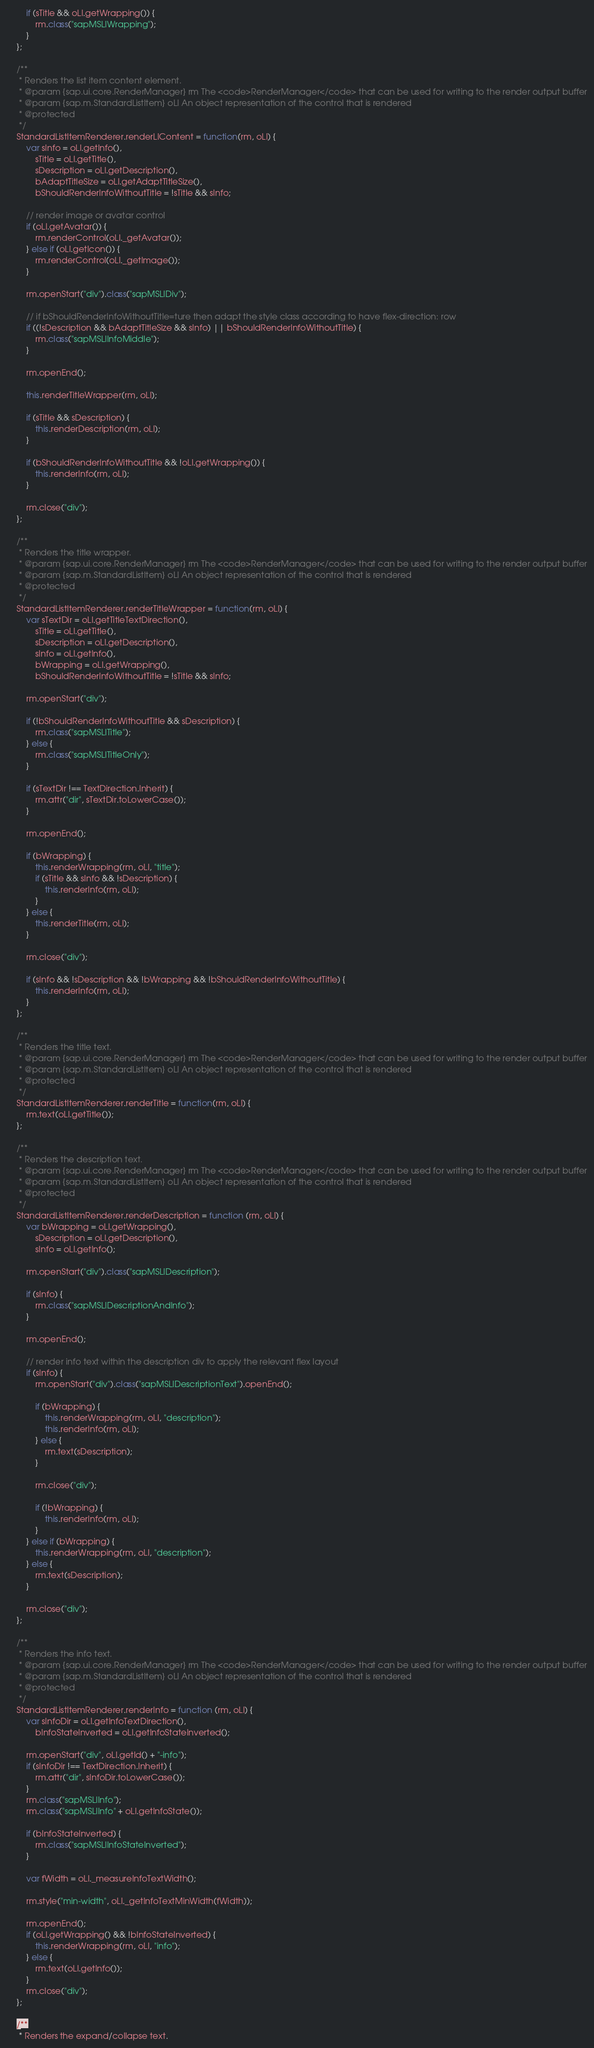<code> <loc_0><loc_0><loc_500><loc_500><_JavaScript_>		if (sTitle && oLI.getWrapping()) {
			rm.class("sapMSLIWrapping");
		}
	};

	/**
	 * Renders the list item content element.
	 * @param {sap.ui.core.RenderManager} rm The <code>RenderManager</code> that can be used for writing to the render output buffer
	 * @param {sap.m.StandardListItem} oLI An object representation of the control that is rendered
	 * @protected
	 */
	StandardListItemRenderer.renderLIContent = function(rm, oLI) {
		var sInfo = oLI.getInfo(),
			sTitle = oLI.getTitle(),
			sDescription = oLI.getDescription(),
			bAdaptTitleSize = oLI.getAdaptTitleSize(),
			bShouldRenderInfoWithoutTitle = !sTitle && sInfo;

		// render image or avatar control
		if (oLI.getAvatar()) {
			rm.renderControl(oLI._getAvatar());
		} else if (oLI.getIcon()) {
			rm.renderControl(oLI._getImage());
		}

		rm.openStart("div").class("sapMSLIDiv");

		// if bShouldRenderInfoWithoutTitle=ture then adapt the style class according to have flex-direction: row
		if ((!sDescription && bAdaptTitleSize && sInfo) || bShouldRenderInfoWithoutTitle) {
			rm.class("sapMSLIInfoMiddle");
		}

		rm.openEnd();

		this.renderTitleWrapper(rm, oLI);

		if (sTitle && sDescription) {
			this.renderDescription(rm, oLI);
		}

		if (bShouldRenderInfoWithoutTitle && !oLI.getWrapping()) {
			this.renderInfo(rm, oLI);
		}

		rm.close("div");
	};

	/**
	 * Renders the title wrapper.
	 * @param {sap.ui.core.RenderManager} rm The <code>RenderManager</code> that can be used for writing to the render output buffer
	 * @param {sap.m.StandardListItem} oLI An object representation of the control that is rendered
	 * @protected
	 */
	StandardListItemRenderer.renderTitleWrapper = function(rm, oLI) {
		var sTextDir = oLI.getTitleTextDirection(),
			sTitle = oLI.getTitle(),
			sDescription = oLI.getDescription(),
			sInfo = oLI.getInfo(),
			bWrapping = oLI.getWrapping(),
			bShouldRenderInfoWithoutTitle = !sTitle && sInfo;

		rm.openStart("div");

		if (!bShouldRenderInfoWithoutTitle && sDescription) {
			rm.class("sapMSLITitle");
		} else {
			rm.class("sapMSLITitleOnly");
		}

		if (sTextDir !== TextDirection.Inherit) {
			rm.attr("dir", sTextDir.toLowerCase());
		}

		rm.openEnd();

		if (bWrapping) {
			this.renderWrapping(rm, oLI, "title");
			if (sTitle && sInfo && !sDescription) {
				this.renderInfo(rm, oLI);
			}
		} else {
			this.renderTitle(rm, oLI);
		}

		rm.close("div");

		if (sInfo && !sDescription && !bWrapping && !bShouldRenderInfoWithoutTitle) {
			this.renderInfo(rm, oLI);
		}
	};

	/**
	 * Renders the title text.
	 * @param {sap.ui.core.RenderManager} rm The <code>RenderManager</code> that can be used for writing to the render output buffer
	 * @param {sap.m.StandardListItem} oLI An object representation of the control that is rendered
	 * @protected
	 */
	StandardListItemRenderer.renderTitle = function(rm, oLI) {
		rm.text(oLI.getTitle());
	};

	/**
	 * Renders the description text.
	 * @param {sap.ui.core.RenderManager} rm The <code>RenderManager</code> that can be used for writing to the render output buffer
	 * @param {sap.m.StandardListItem} oLI An object representation of the control that is rendered
	 * @protected
	 */
	StandardListItemRenderer.renderDescription = function (rm, oLI) {
		var bWrapping = oLI.getWrapping(),
			sDescription = oLI.getDescription(),
			sInfo = oLI.getInfo();

		rm.openStart("div").class("sapMSLIDescription");

		if (sInfo) {
			rm.class("sapMSLIDescriptionAndInfo");
		}

		rm.openEnd();

		// render info text within the description div to apply the relevant flex layout
		if (sInfo) {
			rm.openStart("div").class("sapMSLIDescriptionText").openEnd();

			if (bWrapping) {
				this.renderWrapping(rm, oLI, "description");
				this.renderInfo(rm, oLI);
			} else {
				rm.text(sDescription);
			}

			rm.close("div");

			if (!bWrapping) {
				this.renderInfo(rm, oLI);
			}
		} else if (bWrapping) {
			this.renderWrapping(rm, oLI, "description");
		} else {
			rm.text(sDescription);
		}

		rm.close("div");
	};

	/**
	 * Renders the info text.
	 * @param {sap.ui.core.RenderManager} rm The <code>RenderManager</code> that can be used for writing to the render output buffer
	 * @param {sap.m.StandardListItem} oLI An object representation of the control that is rendered
	 * @protected
	 */
	StandardListItemRenderer.renderInfo = function (rm, oLI) {
		var sInfoDir = oLI.getInfoTextDirection(),
			bInfoStateInverted = oLI.getInfoStateInverted();

		rm.openStart("div", oLI.getId() + "-info");
		if (sInfoDir !== TextDirection.Inherit) {
			rm.attr("dir", sInfoDir.toLowerCase());
		}
		rm.class("sapMSLIInfo");
		rm.class("sapMSLIInfo" + oLI.getInfoState());

		if (bInfoStateInverted) {
			rm.class("sapMSLIInfoStateInverted");
		}

		var fWidth = oLI._measureInfoTextWidth();

		rm.style("min-width", oLI._getInfoTextMinWidth(fWidth));

		rm.openEnd();
		if (oLI.getWrapping() && !bInfoStateInverted) {
			this.renderWrapping(rm, oLI, "info");
		} else {
			rm.text(oLI.getInfo());
		}
		rm.close("div");
	};

	/**
	 * Renders the expand/collapse text.</code> 